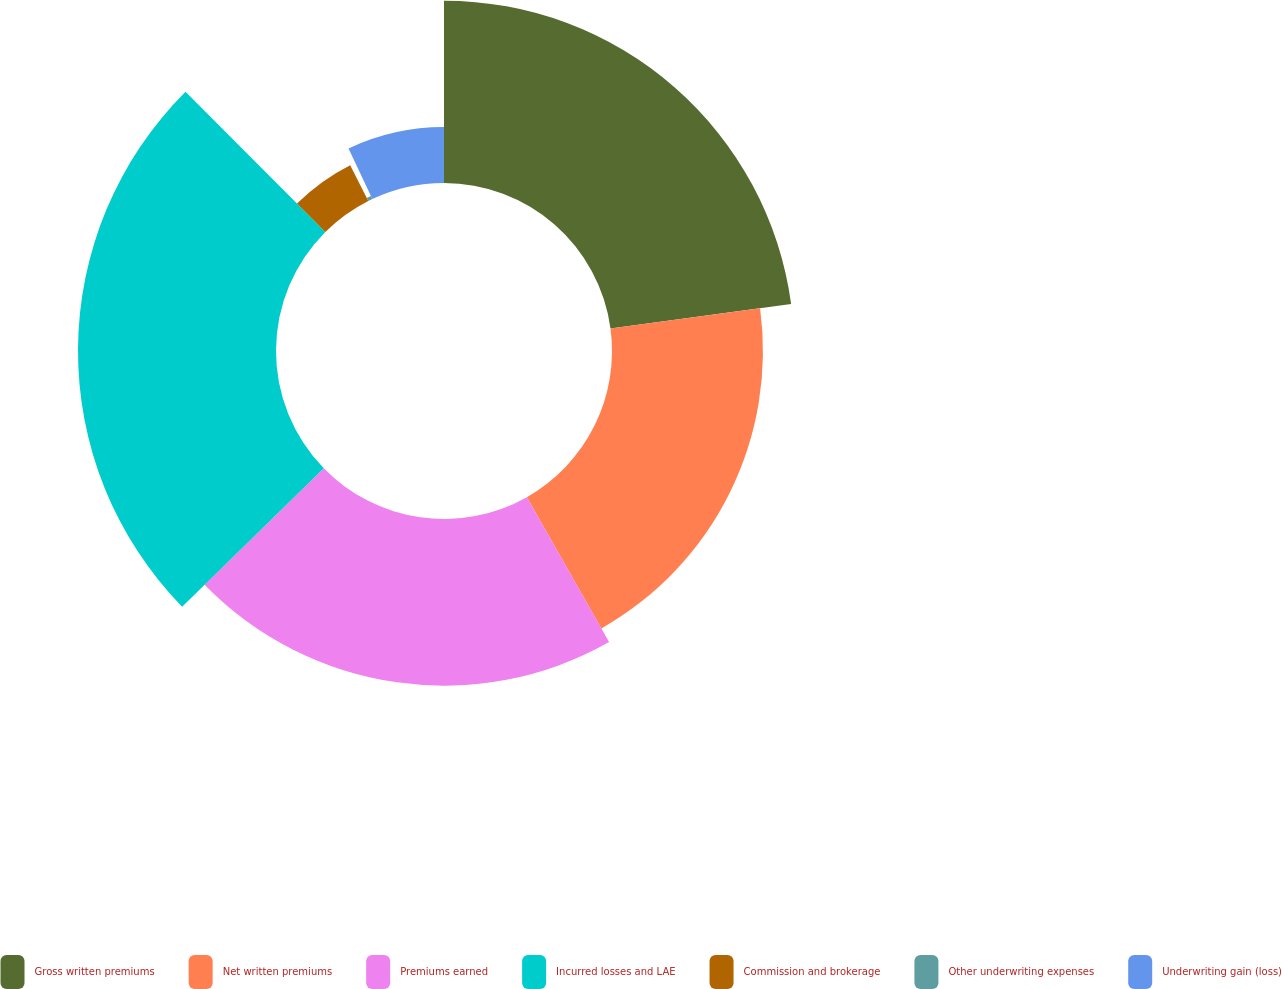<chart> <loc_0><loc_0><loc_500><loc_500><pie_chart><fcel>Gross written premiums<fcel>Net written premiums<fcel>Premiums earned<fcel>Incurred losses and LAE<fcel>Commission and brokerage<fcel>Other underwriting expenses<fcel>Underwriting gain (loss)<nl><fcel>22.86%<fcel>18.93%<fcel>20.9%<fcel>24.83%<fcel>5.04%<fcel>0.43%<fcel>7.01%<nl></chart> 